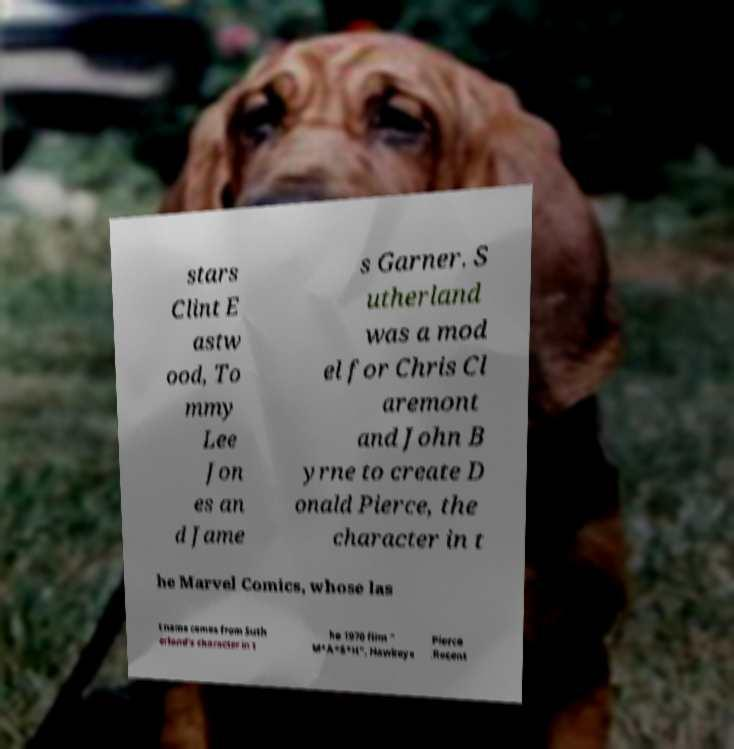Please read and relay the text visible in this image. What does it say? stars Clint E astw ood, To mmy Lee Jon es an d Jame s Garner. S utherland was a mod el for Chris Cl aremont and John B yrne to create D onald Pierce, the character in t he Marvel Comics, whose las t name comes from Suth erland's character in t he 1970 film " M*A*S*H", Hawkeye Pierce .Recent 